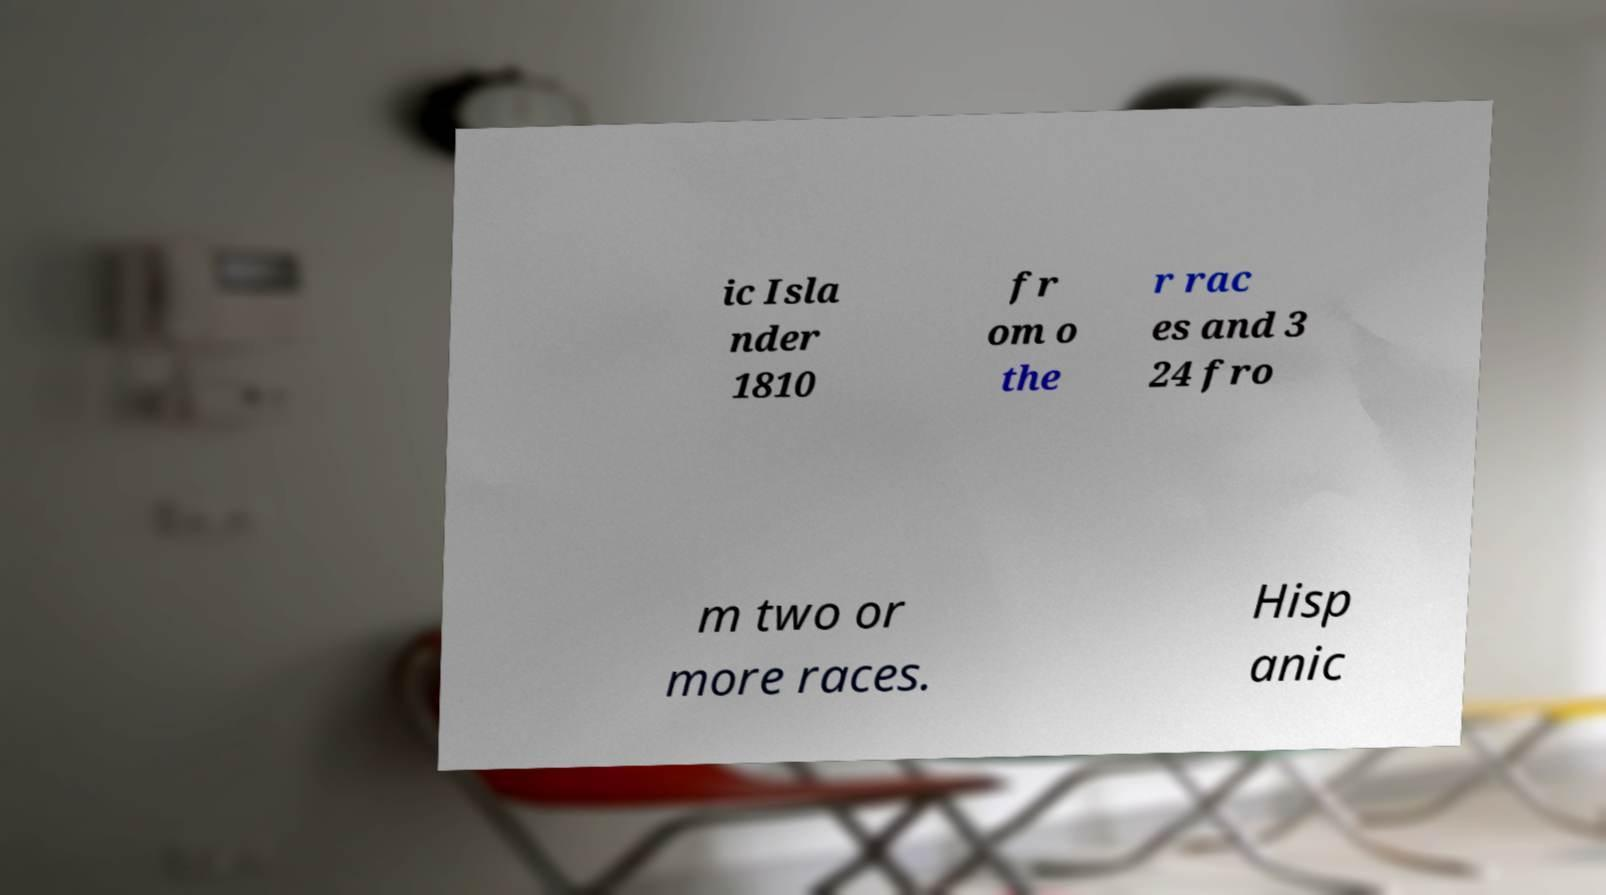Can you accurately transcribe the text from the provided image for me? ic Isla nder 1810 fr om o the r rac es and 3 24 fro m two or more races. Hisp anic 